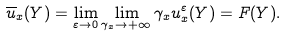Convert formula to latex. <formula><loc_0><loc_0><loc_500><loc_500>\overline { u } _ { x } ( Y ) = \lim _ { \varepsilon \to 0 } \lim _ { \gamma _ { x } \to + \infty } \gamma _ { x } u _ { x } ^ { \varepsilon } ( Y ) = F ( Y ) .</formula> 